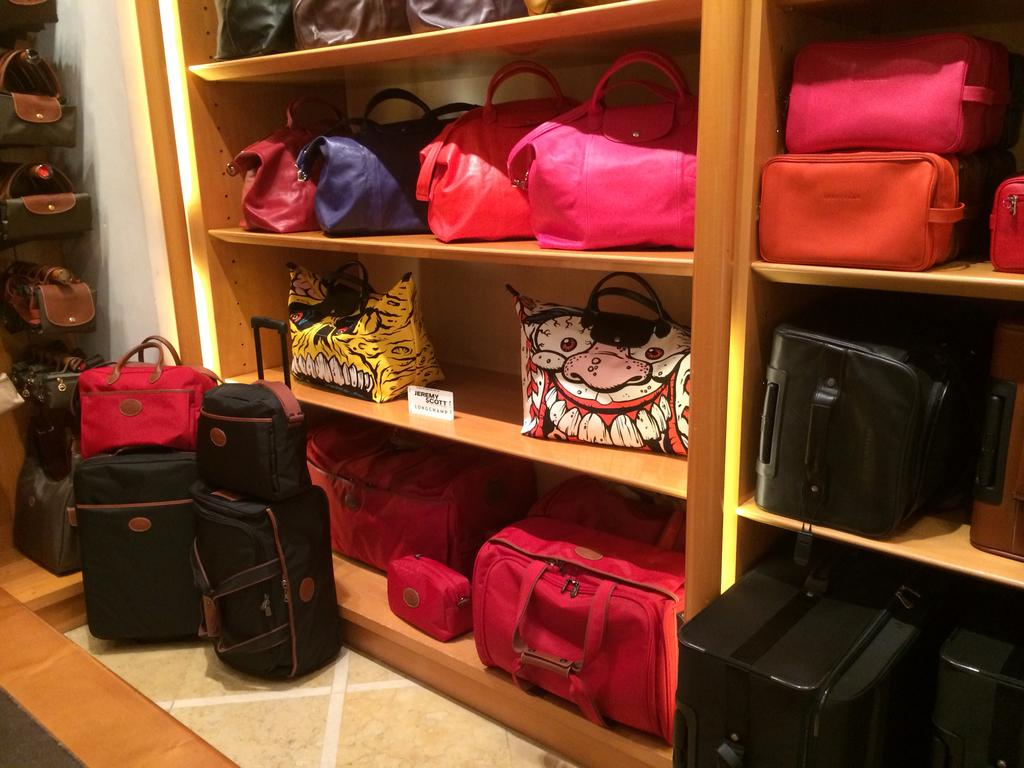What can be seen on the shelves in the image? The shelves are filled with bags. How many shelves are visible in the image? The provided facts do not specify the number of shelves, so we cannot determine that from the information given. How many friends are present in the image? There is no mention of friends in the image, as it only features shelves filled with bags. What time of day is depicted in the image? The provided facts do not give any information about the time of day, so we cannot determine that from the information given. 